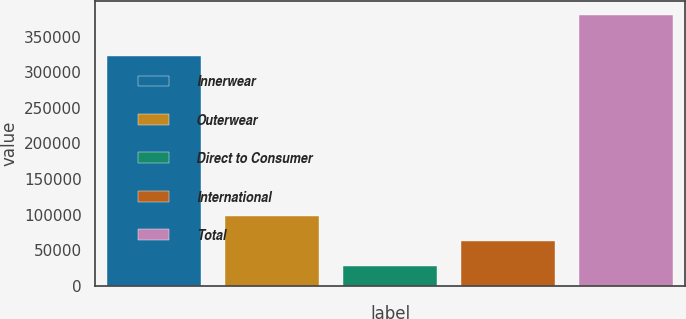Convert chart. <chart><loc_0><loc_0><loc_500><loc_500><bar_chart><fcel>Innerwear<fcel>Outerwear<fcel>Direct to Consumer<fcel>International<fcel>Total<nl><fcel>322564<fcel>97963.4<fcel>27238<fcel>62600.7<fcel>380865<nl></chart> 